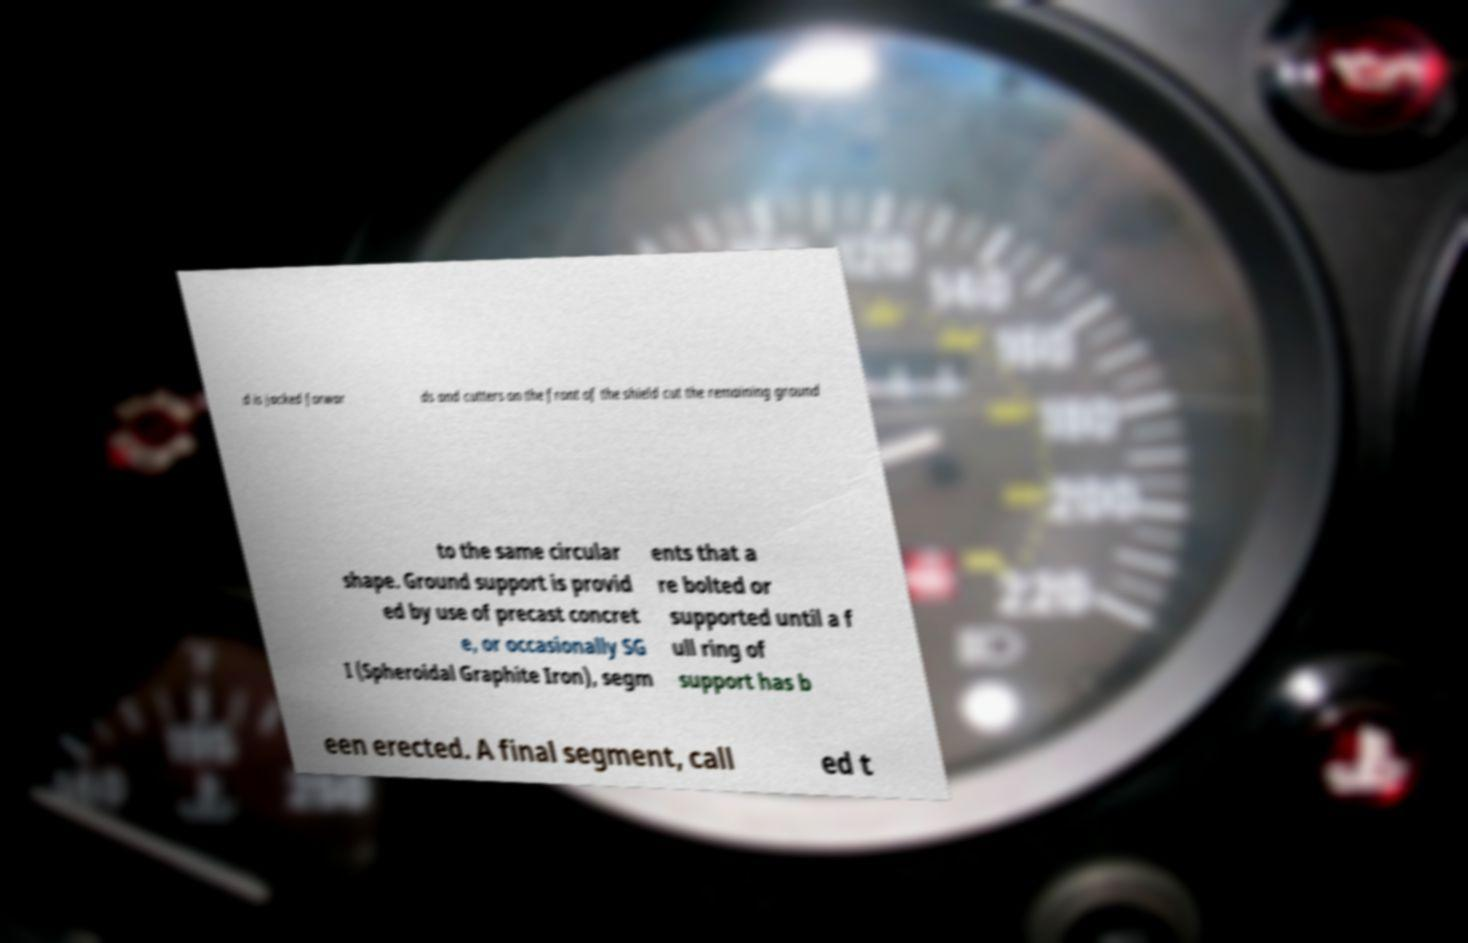Can you accurately transcribe the text from the provided image for me? d is jacked forwar ds and cutters on the front of the shield cut the remaining ground to the same circular shape. Ground support is provid ed by use of precast concret e, or occasionally SG I (Spheroidal Graphite Iron), segm ents that a re bolted or supported until a f ull ring of support has b een erected. A final segment, call ed t 